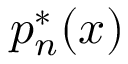Convert formula to latex. <formula><loc_0><loc_0><loc_500><loc_500>p _ { n } ^ { * } ( x )</formula> 